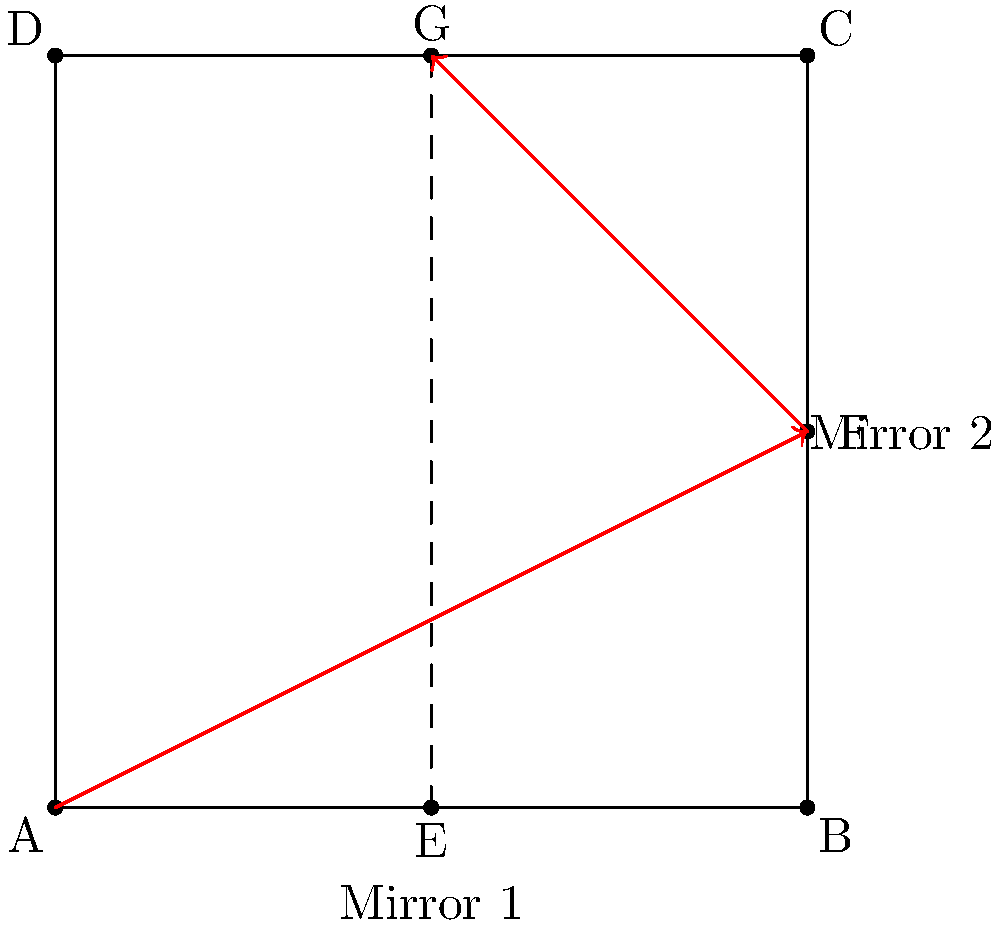In the optical setup shown above, a light ray originates from point A and reflects off two mirrors (AB and BC) before reaching point G. If the square ABCD has a side length of 4 units, what is the total distance traveled by the light ray from A to G? Let's approach this step-by-step:

1) First, we need to identify the path of the light ray. It starts at A, reflects off mirror AB at point E, then reflects off mirror BC at point F, and finally reaches G.

2) The path is therefore AEF + FG.

3) To find AE:
   - AE is the hypotenuse of right triangle AEO, where O is the origin (0,0).
   - AO = 0, EO = 2
   - $AE = \sqrt{0^2 + 2^2} = 2$ units

4) To find EF:
   - EF is the hypotenuse of right triangle EFO, where O is (2,0).
   - EO = 2, FO = 2
   - $EF = \sqrt{2^2 + 2^2} = 2\sqrt{2}$ units

5) To find FG:
   - FG is the hypotenuse of right triangle FGO, where O is (4,2).
   - FO = 0, GO = 2
   - $FG = \sqrt{0^2 + 2^2} = 2$ units

6) Total distance = AE + EF + FG
                  = $2 + 2\sqrt{2} + 2$
                  = $4 + 2\sqrt{2}$ units

Therefore, the total distance traveled by the light ray is $4 + 2\sqrt{2}$ units.
Answer: $4 + 2\sqrt{2}$ units 